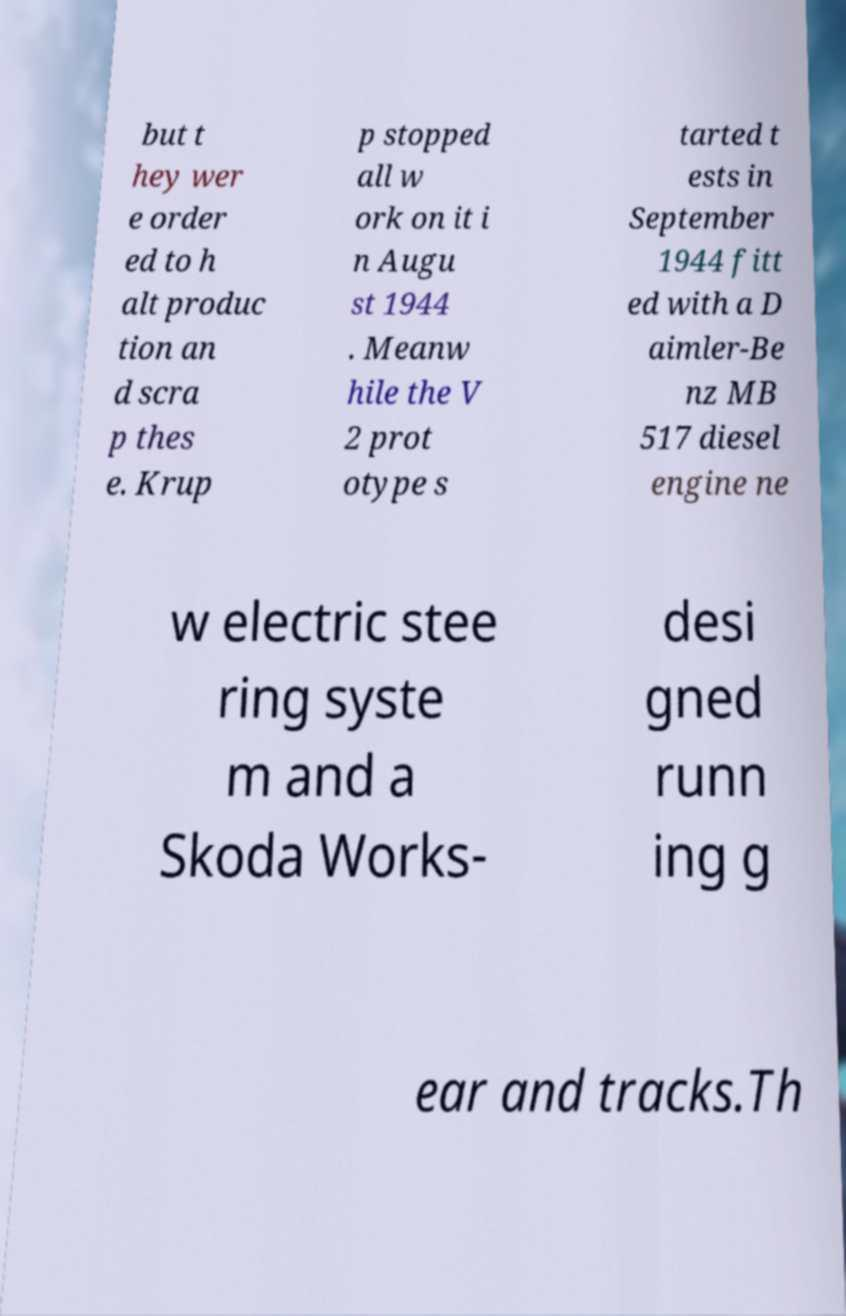Can you accurately transcribe the text from the provided image for me? but t hey wer e order ed to h alt produc tion an d scra p thes e. Krup p stopped all w ork on it i n Augu st 1944 . Meanw hile the V 2 prot otype s tarted t ests in September 1944 fitt ed with a D aimler-Be nz MB 517 diesel engine ne w electric stee ring syste m and a Skoda Works- desi gned runn ing g ear and tracks.Th 